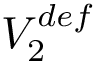<formula> <loc_0><loc_0><loc_500><loc_500>V _ { 2 } ^ { d e f }</formula> 